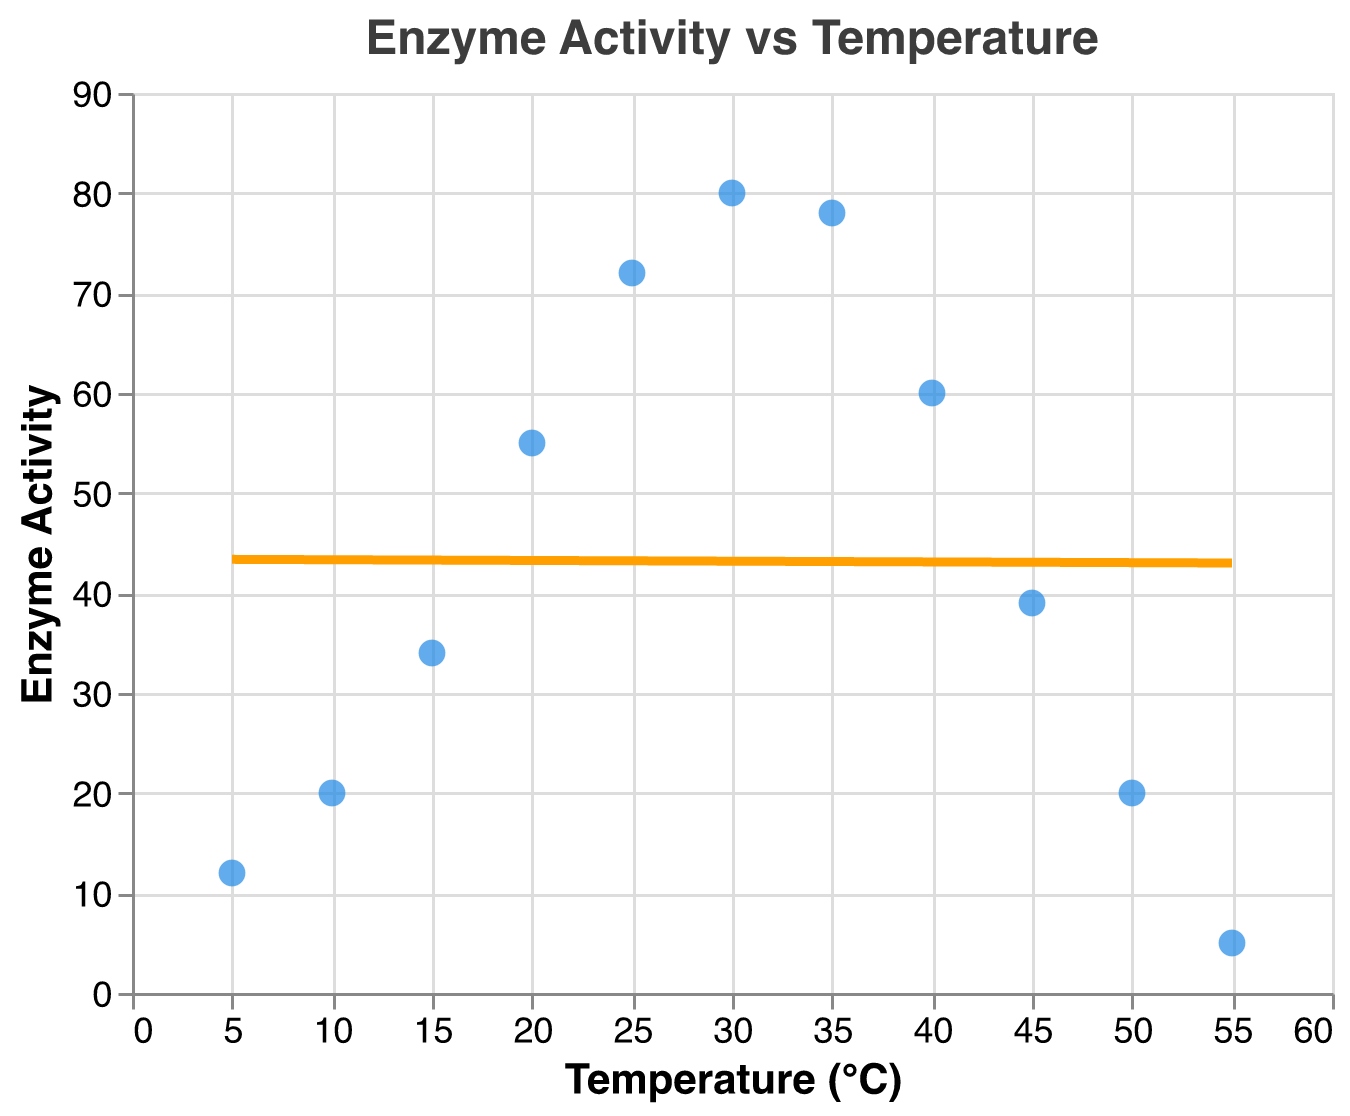What is the title of the scatter plot? The title of the plot is displayed at the top.
Answer: Enzyme Activity vs Temperature How many data points are shown in the scatter plot? Count the number of individual points plotted on the graph.
Answer: 11 What is the temperature when enzyme activity is at its maximum? Locate the highest point on the y-axis (enzyme activity) and find the corresponding x-axis (temperature) value.
Answer: 30°C What is the trend in enzyme activity as temperature increases from 5°C to 30°C? Observe the slope of the trend line and the points plotted from 5°C to 30°C. Enzyme activity increases as the temperature rises from 5°C to 30°C.
Answer: Increases At what temperature does the enzyme activity start to decline? Identify the highest point of the enzyme activity, then look for the temperature after which the activity decreases.
Answer: 30°C Compare enzyme activity at 20°C and 40°C. Which temperature shows higher activity? Find the points corresponding to 20°C and 40°C on the x-axis, and compare their y-axis values (enzyme activity).
Answer: 20°C What is the range of enzyme activity values shown in the scatter plot? Find the minimum and maximum values of enzyme activity on the y-axis.
Answer: 5 to 80 Is there a temperature at which enzyme activity is zero? Look at the plot to see if any point has an enzyme activity of zero.
Answer: No How does the trend line fit the data points overall? Visually assess how well the regression line fits the scatter plot data points. The trend line should generally follow the increase and then decrease in enzyme activity.
Answer: It fits well, showing an increase and then decrease What is the approximate enzyme activity at 35°C according to the trend line? Find the point on the trend line where the temperature is 35°C and read the corresponding enzyme activity.
Answer: Approximately 78 